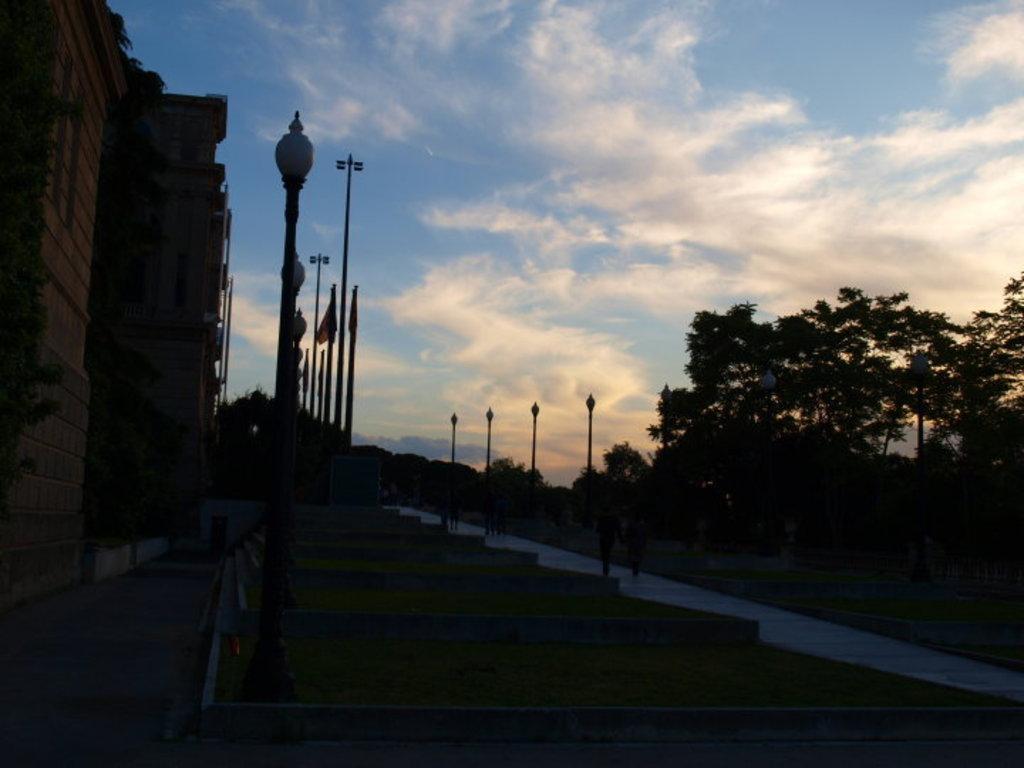Can you describe this image briefly? At the bottom of the image there are steps. And also there are poles with lamps and flags. In the background there are trees. And on the left side of the image there is a building. At the top of the image there is sky with clouds.  